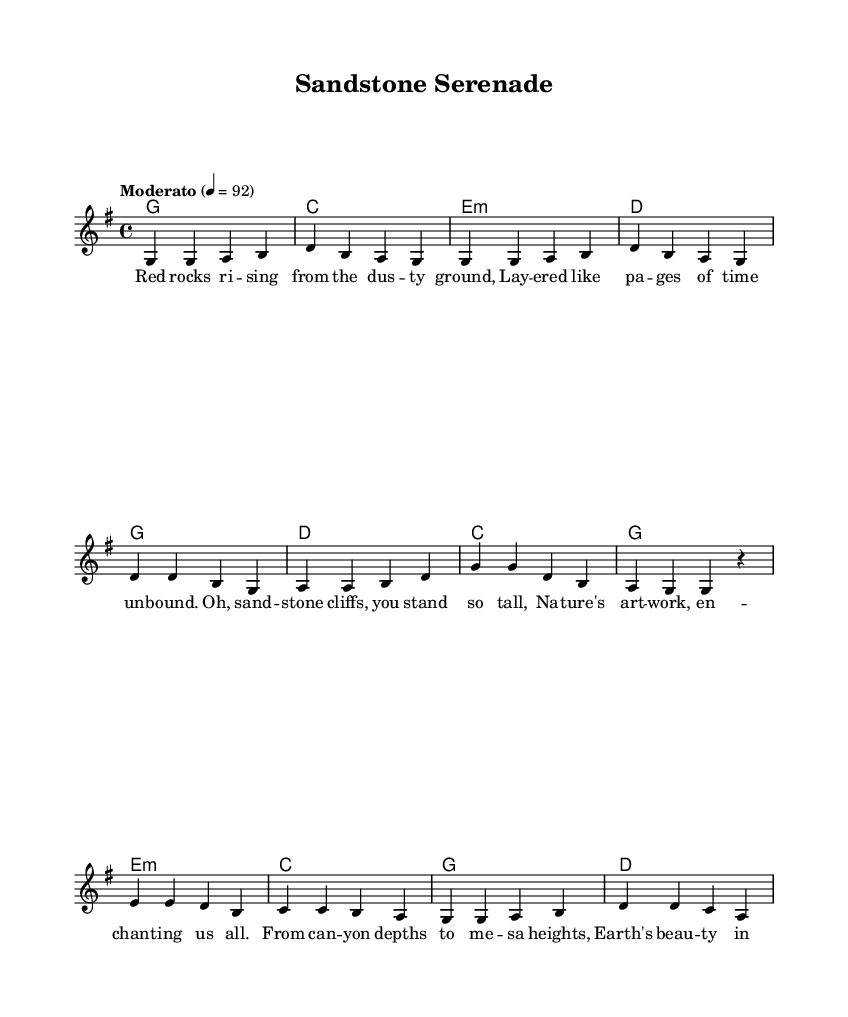What is the key signature of this music? The key signature is indicated by the number of sharps or flats at the beginning of the staff. In this case, there are no sharps or flats, indicating it is in G major.
Answer: G major What is the time signature of this music? The time signature is shown at the beginning of the music, represented by two numbers, one on top of the other. In this case, it is 4/4, meaning there are four beats per measure.
Answer: 4/4 What is the tempo marking for this piece? The tempo marking is a descriptive term at the beginning of the piece indicating the speed. Here, it is marked "Moderato," suggesting a moderate pace, and the metronome marking is 92 beats per minute.
Answer: Moderato How many verses are included in the score? By examining the lyric section, it reveals there is one complete verse provided in the score. There are no indications of additional verses present.
Answer: One Identify a poetic feature used in the lyrics. The lyrics contain rhyme, where the ends of phrases rhyme with each other, such as "unbound" with "all" and "heights" with "sights," creating a musical and lyrical flow typical in country folk songs.
Answer: Rhyme What type of landscape is described in the lyrics? The lyrics evoke imagery associated with natural landforms such as "sandstone cliffs," "red rocks," and "canyon depths," which are typical in country songs that celebrate nature.
Answer: Natural landscapes How does the bridge differ from the verse in melody? The bridge typically introduces a different melody to provide contrast to the verse. Here, the melody transitions into a slightly different sequence of notes compared to the verse, emphasizing a change in the musical narrative.
Answer: Different melody 